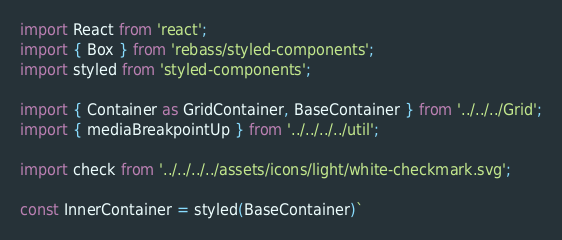Convert code to text. <code><loc_0><loc_0><loc_500><loc_500><_JavaScript_>import React from 'react';
import { Box } from 'rebass/styled-components';
import styled from 'styled-components';

import { Container as GridContainer, BaseContainer } from '../../../Grid';
import { mediaBreakpointUp } from '../../../../util';

import check from '../../../../assets/icons/light/white-checkmark.svg';

const InnerContainer = styled(BaseContainer)`</code> 